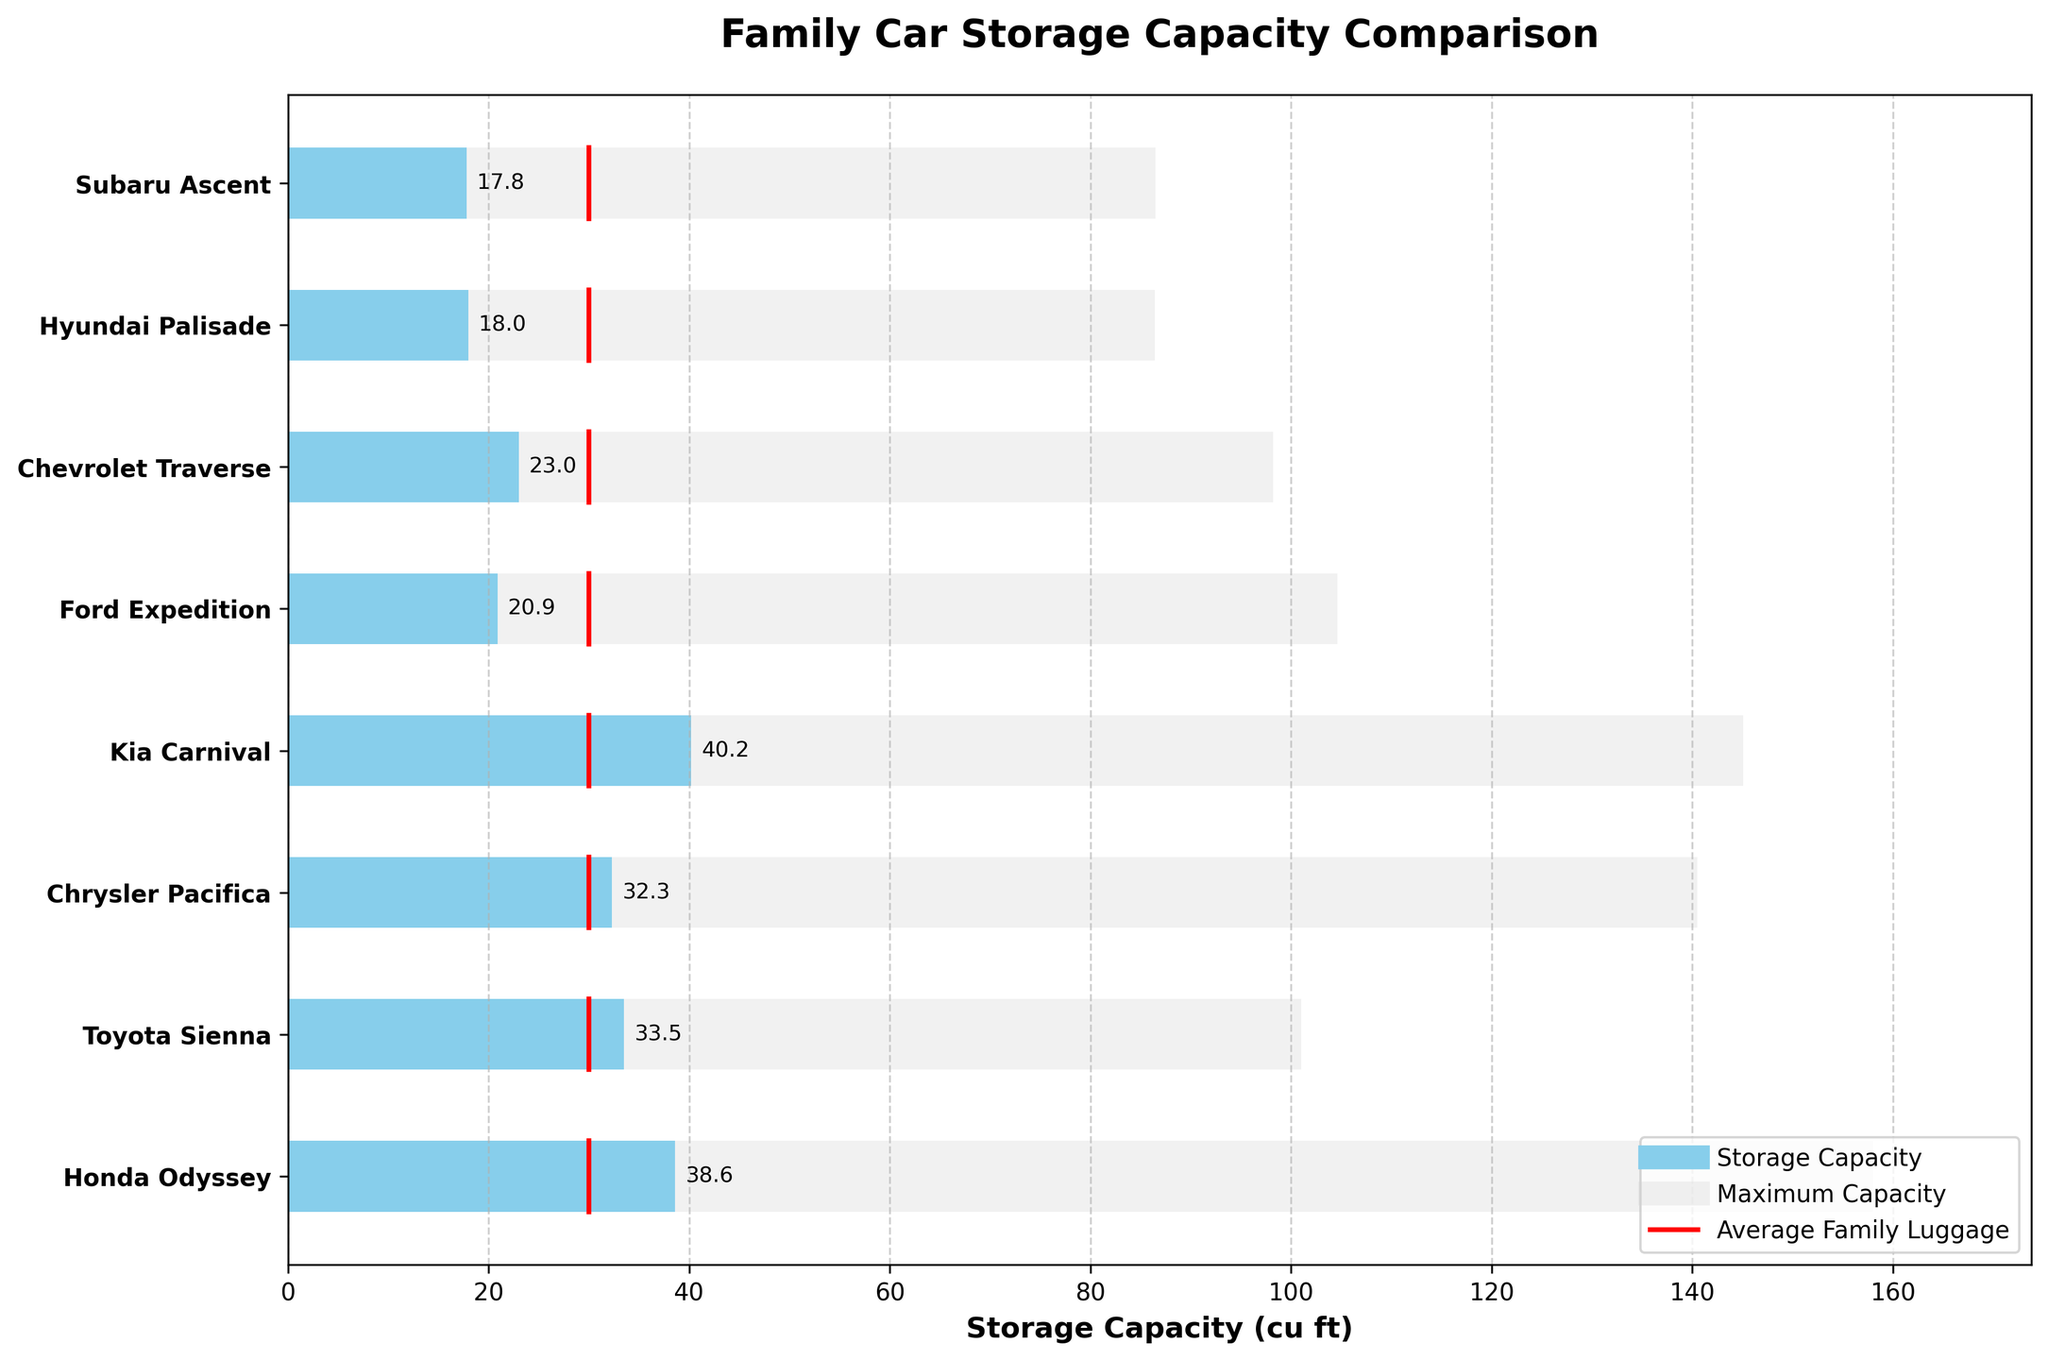What is the title of the plot? The title of the plot is found at the top center. It indicates the subject of the plot.
Answer: Family Car Storage Capacity Comparison How many car models are shown on the plot? Count the number of distinct y-axis labels. There are 8 distinct car models listed.
Answer: 8 What is the significance of the red lines on the plot? Red lines on the plot represent the average family luggage capacity, marked at 30 cu ft for comparison across all car models.
Answer: Average Family Luggage What is the difference in storage capacity between the Kia Carnival and the Hyundai Palisade? Subtract the storage capacity of the Hyundai Palisade (18 cu ft) from the storage capacity of the Kia Carnival (40.2 cu ft). \(40.2 - 18 = 22.2\) cu ft.
Answer: 22.2 cu ft Which car model has the storage capacity closest to the average family luggage requirements? Compare the storage capacities with the average family luggage (30 cu ft). The Chrysler Pacifica has 32.3 cu ft, which is closest.
Answer: Chrysler Pacifica Which car model has the highest storage capacity? Look at the longest blue bar in the plot. The Kia Carnival has the highest storage capacity of 40.2 cu ft.
Answer: Kia Carnival Which car model's storage capacity is below the average family luggage requirement? Identify car models where the blue bar is shorter than the red line at 30 cu ft. The models are Ford Expedition, Chevrolet Traverse, Hyundai Palisade, and Subaru Ascent.
Answer: Ford Expedition, Chevrolet Traverse, Hyundai Palisade, Subaru Ascent Which car model offers the maximum overall capacity? Look at the car model with the longest light grey bar. The Honda Odyssey has the largest maximum capacity of 158 cu ft.
Answer: Honda Odyssey Which car model has the smallest difference between its storage capacity and its maximum capacity? Calculate the difference between storage and maximum capacities for each car model. The Toyota Sienna has a storage capacity of 33.5 cu ft and a maximum capacity of 101 cu ft. Hence, its difference is \( 101 - 33.5 = 67.5 \) cu ft. Comparing this with other models, Toyota Sienna has the smallest range.
Answer: Toyota Sienna Which family car has a storage capacity that exceeds the average family luggage requirement by the largest margin? Calculate the difference between the storage capacity and average luggage (30 cu ft). The Kia Carnival exceeds by \( 40.2 - 30 = 10.2 \) cu ft. The Honda Odyssey comes close with \( 38.6 - 30 = 8.6 \) cu ft. Kia Carnival has the largest margin.
Answer: Kia Carnival 